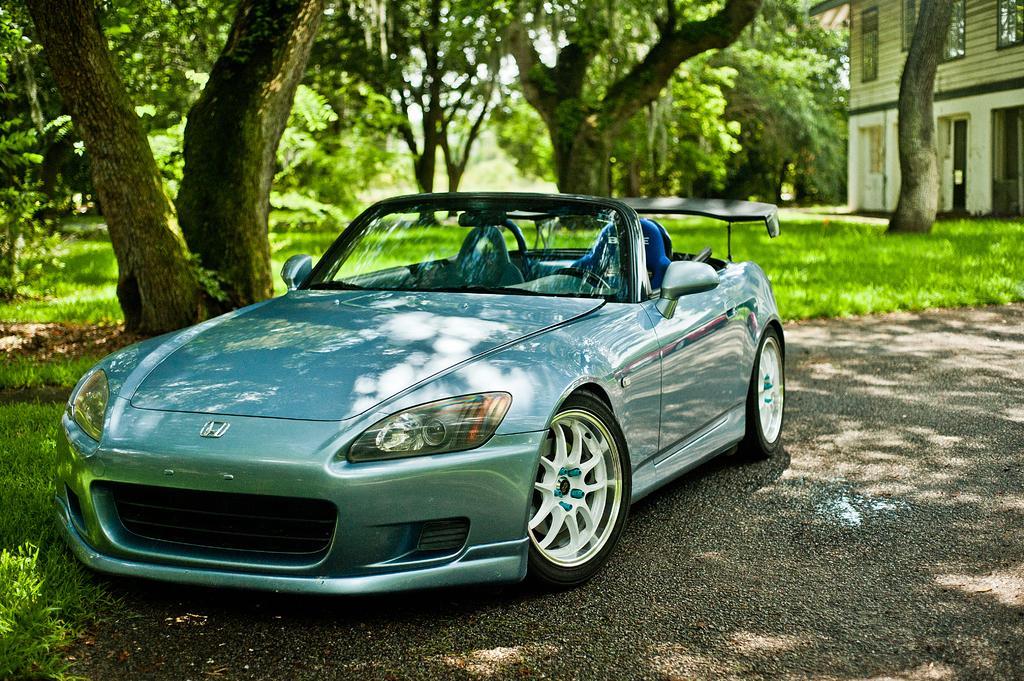In one or two sentences, can you explain what this image depicts? In the middle I can see a car on the road. In the background I can see grass, trees, the sky and a building. This image is taken during a sunny day. 